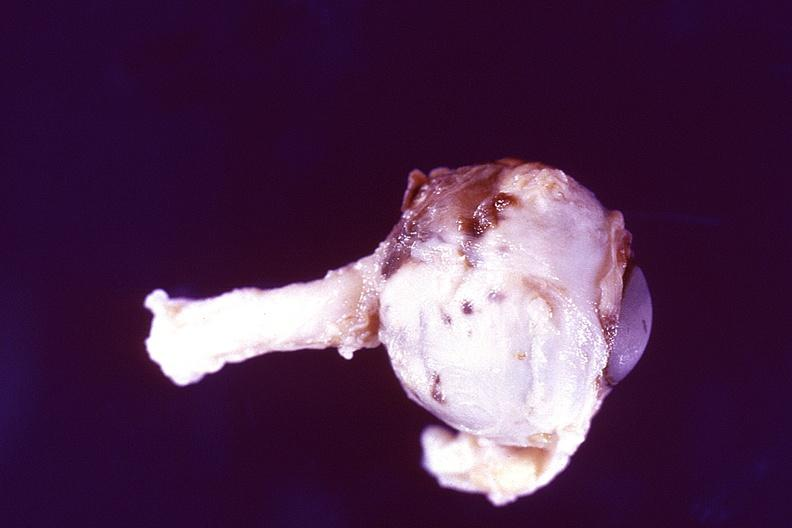s mucoepidermoid carcinoma present?
Answer the question using a single word or phrase. No 